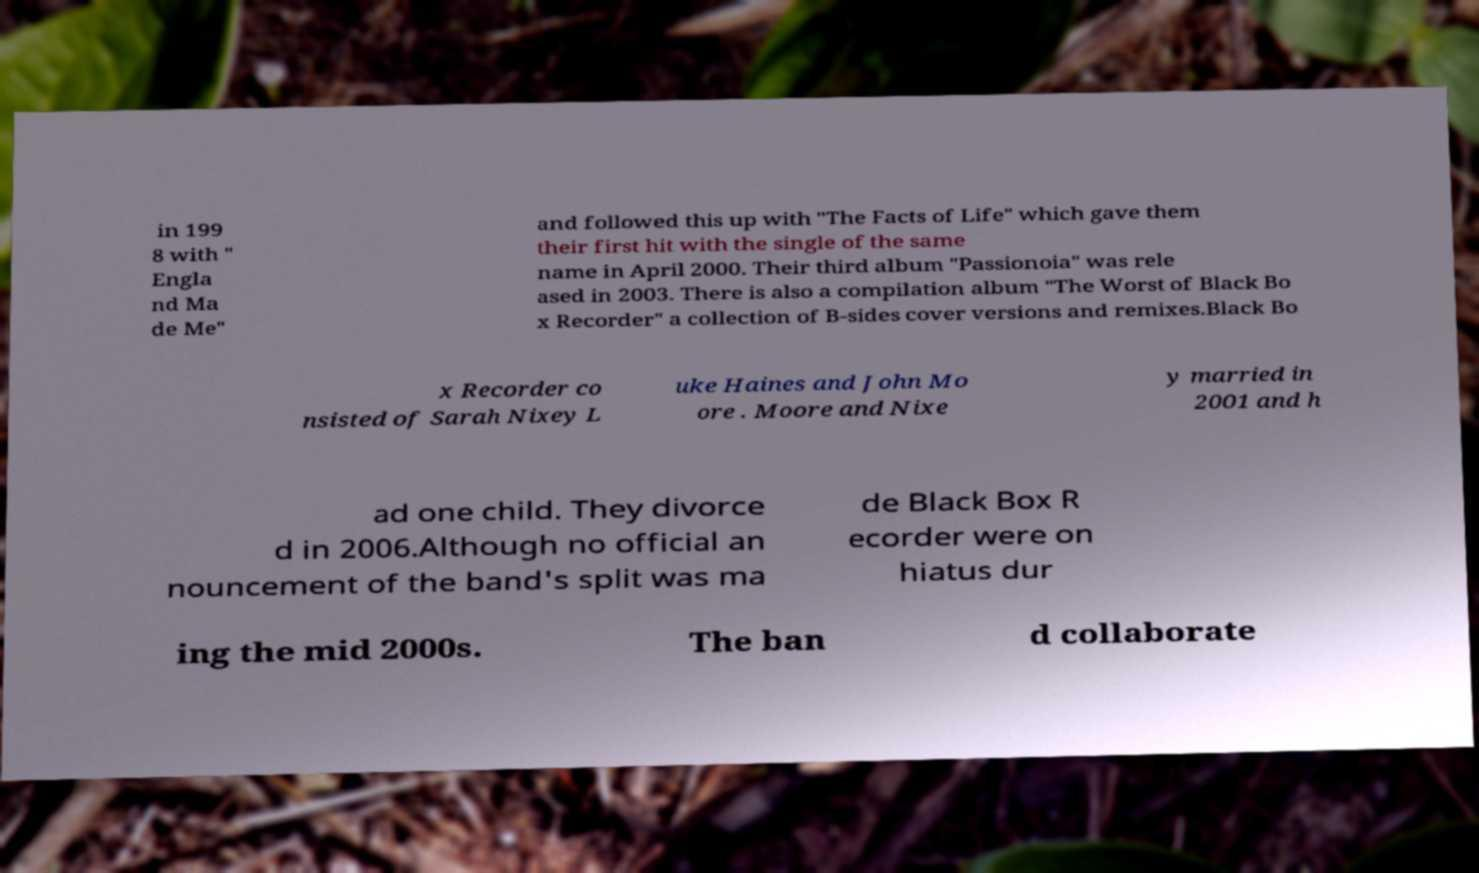Can you accurately transcribe the text from the provided image for me? in 199 8 with " Engla nd Ma de Me" and followed this up with "The Facts of Life" which gave them their first hit with the single of the same name in April 2000. Their third album "Passionoia" was rele ased in 2003. There is also a compilation album "The Worst of Black Bo x Recorder" a collection of B-sides cover versions and remixes.Black Bo x Recorder co nsisted of Sarah Nixey L uke Haines and John Mo ore . Moore and Nixe y married in 2001 and h ad one child. They divorce d in 2006.Although no official an nouncement of the band's split was ma de Black Box R ecorder were on hiatus dur ing the mid 2000s. The ban d collaborate 